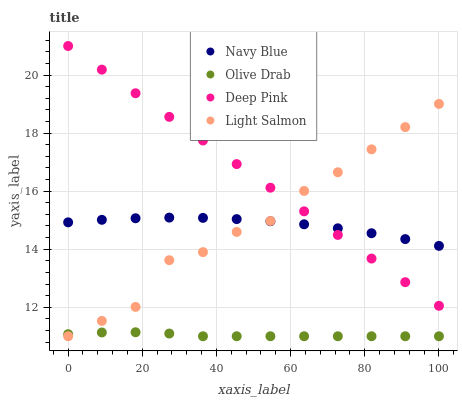Does Olive Drab have the minimum area under the curve?
Answer yes or no. Yes. Does Deep Pink have the maximum area under the curve?
Answer yes or no. Yes. Does Light Salmon have the minimum area under the curve?
Answer yes or no. No. Does Light Salmon have the maximum area under the curve?
Answer yes or no. No. Is Deep Pink the smoothest?
Answer yes or no. Yes. Is Light Salmon the roughest?
Answer yes or no. Yes. Is Light Salmon the smoothest?
Answer yes or no. No. Is Deep Pink the roughest?
Answer yes or no. No. Does Light Salmon have the lowest value?
Answer yes or no. Yes. Does Deep Pink have the lowest value?
Answer yes or no. No. Does Deep Pink have the highest value?
Answer yes or no. Yes. Does Light Salmon have the highest value?
Answer yes or no. No. Is Olive Drab less than Navy Blue?
Answer yes or no. Yes. Is Navy Blue greater than Olive Drab?
Answer yes or no. Yes. Does Light Salmon intersect Deep Pink?
Answer yes or no. Yes. Is Light Salmon less than Deep Pink?
Answer yes or no. No. Is Light Salmon greater than Deep Pink?
Answer yes or no. No. Does Olive Drab intersect Navy Blue?
Answer yes or no. No. 